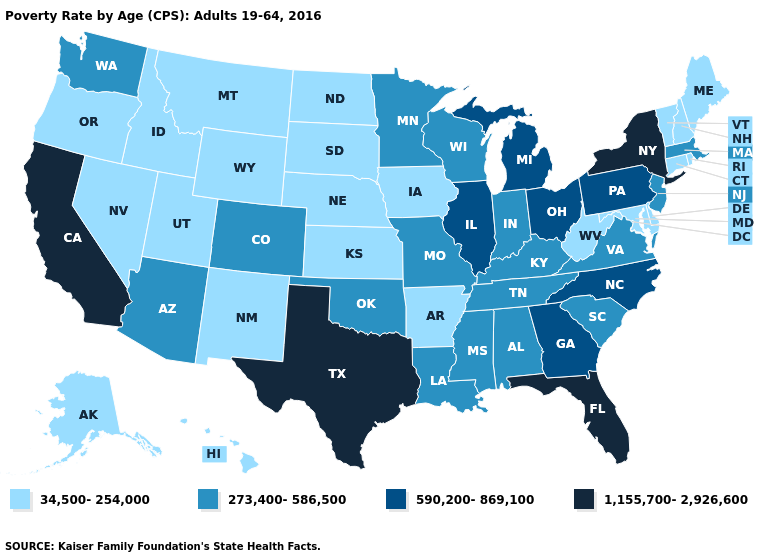Does North Dakota have the lowest value in the USA?
Keep it brief. Yes. Name the states that have a value in the range 1,155,700-2,926,600?
Give a very brief answer. California, Florida, New York, Texas. Which states have the lowest value in the South?
Quick response, please. Arkansas, Delaware, Maryland, West Virginia. Does South Dakota have the same value as Missouri?
Be succinct. No. Which states hav the highest value in the MidWest?
Short answer required. Illinois, Michigan, Ohio. Name the states that have a value in the range 1,155,700-2,926,600?
Keep it brief. California, Florida, New York, Texas. Does Washington have the same value as Utah?
Keep it brief. No. Name the states that have a value in the range 590,200-869,100?
Be succinct. Georgia, Illinois, Michigan, North Carolina, Ohio, Pennsylvania. What is the value of South Dakota?
Concise answer only. 34,500-254,000. Does North Carolina have a higher value than Alabama?
Concise answer only. Yes. Does New Hampshire have a lower value than Mississippi?
Quick response, please. Yes. What is the value of Kansas?
Keep it brief. 34,500-254,000. What is the value of Utah?
Concise answer only. 34,500-254,000. What is the lowest value in the USA?
Quick response, please. 34,500-254,000. What is the value of Colorado?
Quick response, please. 273,400-586,500. 